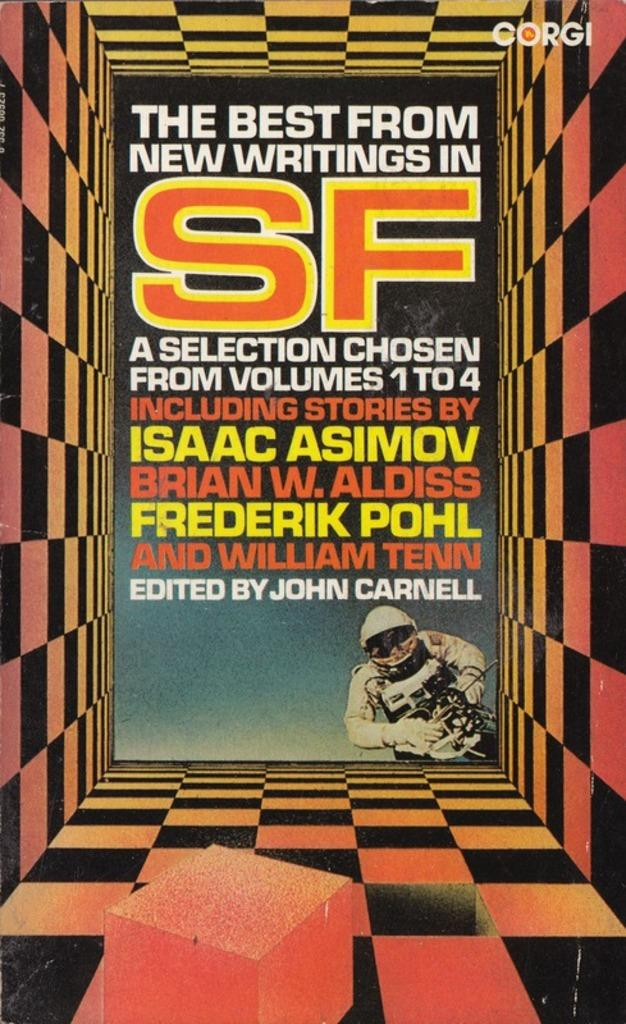<image>
Summarize the visual content of the image. A book cover with an astronaut on the front for writing selections edited by John Carnell. 